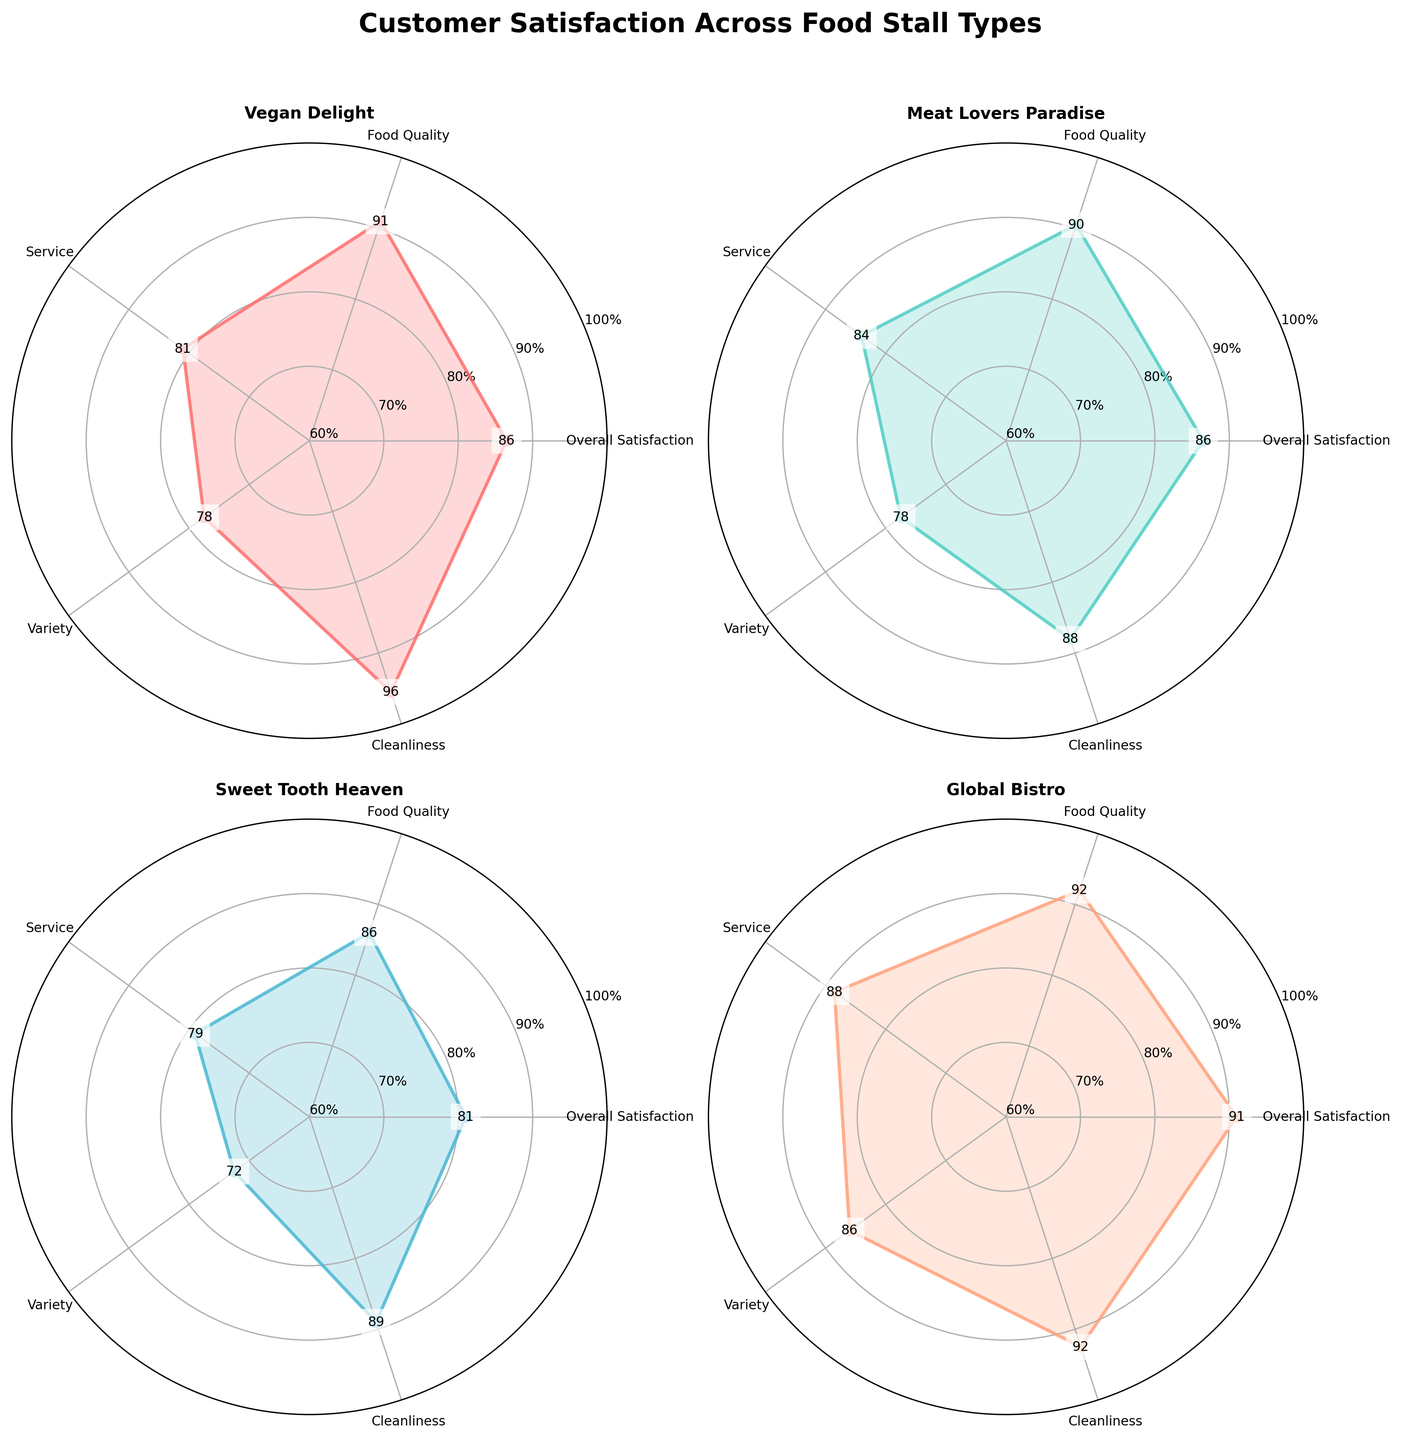What is the title of the figure? The title is typically placed at the top of the figure and is used to summarize the main topic or purpose of the visual representation. Here, it's clearly written at the top of the figure.
Answer: Customer Satisfaction Across Food Stall Types Which food stall has the highest average Food Quality rating? By looking at the radar chart and identifying the values for Food Quality, we see that Global Bistro has the highest value at the outermost point, indicating the highest average Food Quality rating.
Answer: Global Bistro What is the range of y-ticks used in each radar chart? The y-ticks are shown along the radial axis, ranging from the minimum to maximum values indicated on the chart circular grid. The labels for these ticks help determine their range.
Answer: 60% to 100% Which food stall type has the lowest average Service rating? By examining the Service dimension on each radar chart, Sweet Tooth Heaven has the lowest value around that axis, indicating it has the lowest average Service rating.
Answer: Sweet Tooth Heaven What color represents the Meat Lovers Paradise food stall in the radar charts? Each food stall type is represented by a unique color in the radar charts. Meat Lovers Paradise is represented by a teal-like color in the figure.
Answer: Teal Between Vegan Delight and Meat Lovers Paradise, which food stall has higher average Cleanliness? By comparing the Cleanliness values on the radar charts for these two stalls, Vegan Delight has higher values.
Answer: Vegan Delight Which food stall type has the most balanced customer satisfaction across all categories? A balanced chart would mean the values for different categories are close to each other without any extreme highs or lows. Global Bistro has a nearly uniform distribution of high values across all the categories.
Answer: Global Bistro On which food stall's radar chart does the Variety rating appear relatively low? By checking the Variety dimension across the different charts, Sweet Tooth Heaven stands out with its noticeably lower rating for Variety.
Answer: Sweet Tooth Heaven How does Meat Lovers Paradise compare to Vegan Delight in terms of Overall Satisfaction? Comparing the values on the radar charts, Meat Lovers Paradise has a slightly lower Overall Satisfaction rating compared to Vegan Delight.
Answer: Vegan Delight What is the approximate average Overall Satisfaction rating for Global Bistro? By looking at both instances of Global Bistro and averaging their Overall Satisfaction ratings (90 and 92), we get (90 + 92)/2 = 91.
Answer: 91 